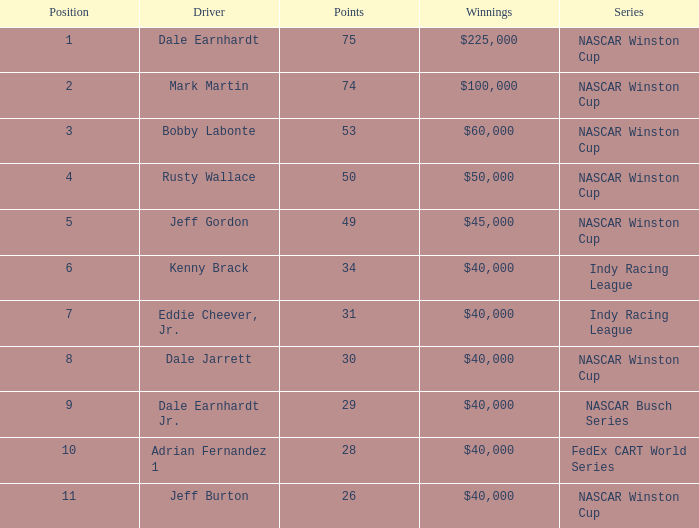Could you help me parse every detail presented in this table? {'header': ['Position', 'Driver', 'Points', 'Winnings', 'Series'], 'rows': [['1', 'Dale Earnhardt', '75', '$225,000', 'NASCAR Winston Cup'], ['2', 'Mark Martin', '74', '$100,000', 'NASCAR Winston Cup'], ['3', 'Bobby Labonte', '53', '$60,000', 'NASCAR Winston Cup'], ['4', 'Rusty Wallace', '50', '$50,000', 'NASCAR Winston Cup'], ['5', 'Jeff Gordon', '49', '$45,000', 'NASCAR Winston Cup'], ['6', 'Kenny Brack', '34', '$40,000', 'Indy Racing League'], ['7', 'Eddie Cheever, Jr.', '31', '$40,000', 'Indy Racing League'], ['8', 'Dale Jarrett', '30', '$40,000', 'NASCAR Winston Cup'], ['9', 'Dale Earnhardt Jr.', '29', '$40,000', 'NASCAR Busch Series'], ['10', 'Adrian Fernandez 1', '28', '$40,000', 'FedEx CART World Series'], ['11', 'Jeff Burton', '26', '$40,000', 'NASCAR Winston Cup']]} In what series did Bobby Labonte drive? NASCAR Winston Cup. 